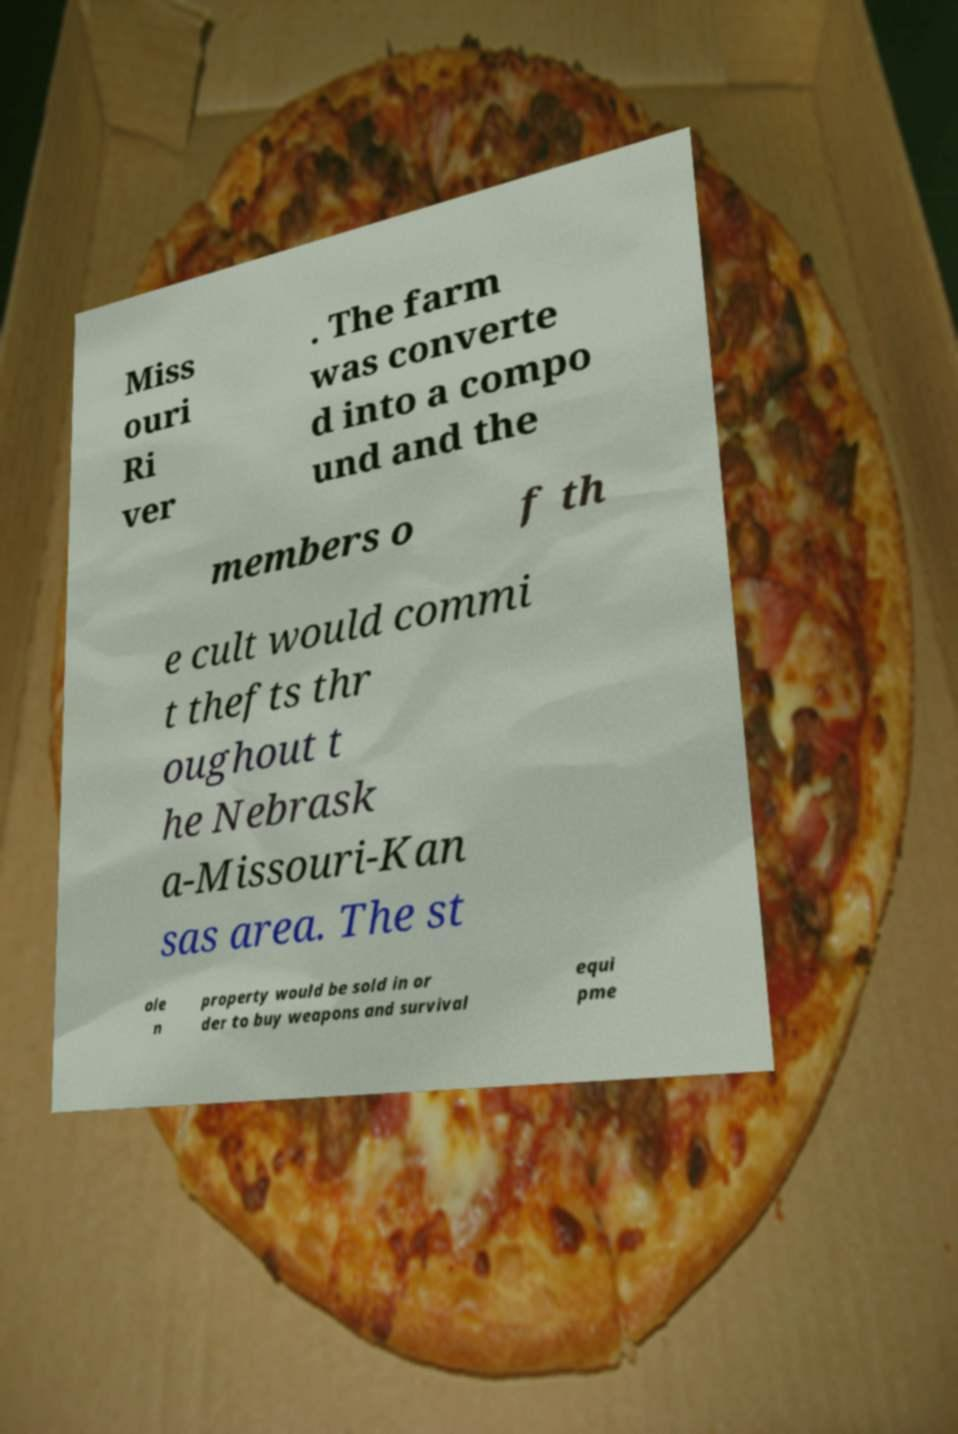Can you read and provide the text displayed in the image?This photo seems to have some interesting text. Can you extract and type it out for me? Miss ouri Ri ver . The farm was converte d into a compo und and the members o f th e cult would commi t thefts thr oughout t he Nebrask a-Missouri-Kan sas area. The st ole n property would be sold in or der to buy weapons and survival equi pme 